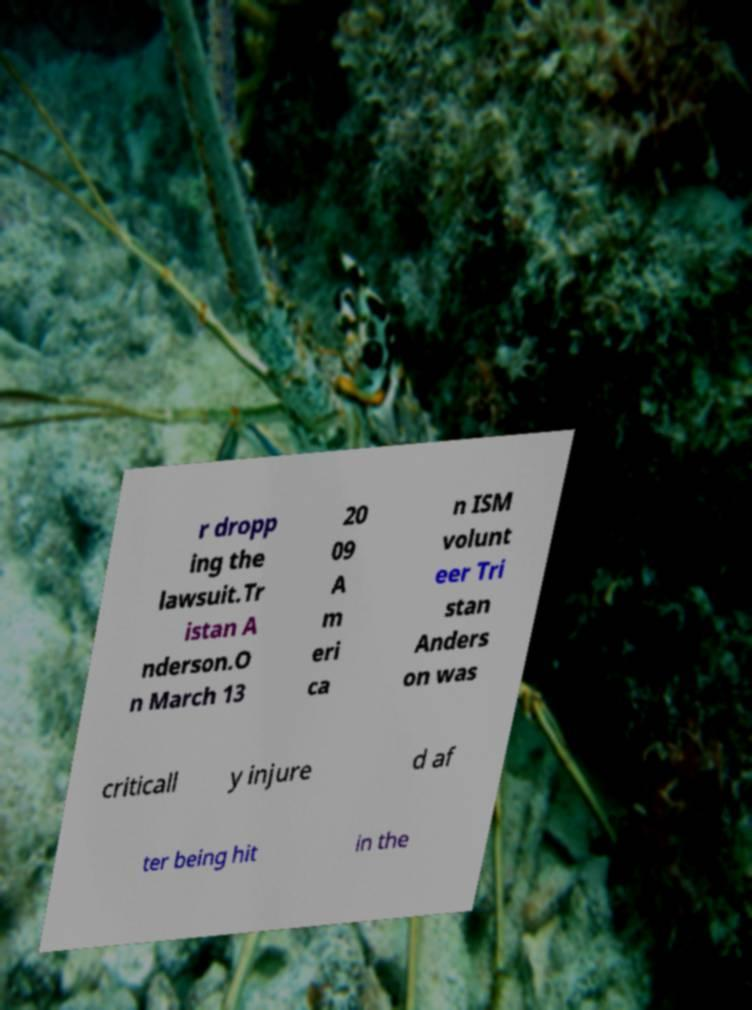Could you extract and type out the text from this image? r dropp ing the lawsuit.Tr istan A nderson.O n March 13 20 09 A m eri ca n ISM volunt eer Tri stan Anders on was criticall y injure d af ter being hit in the 